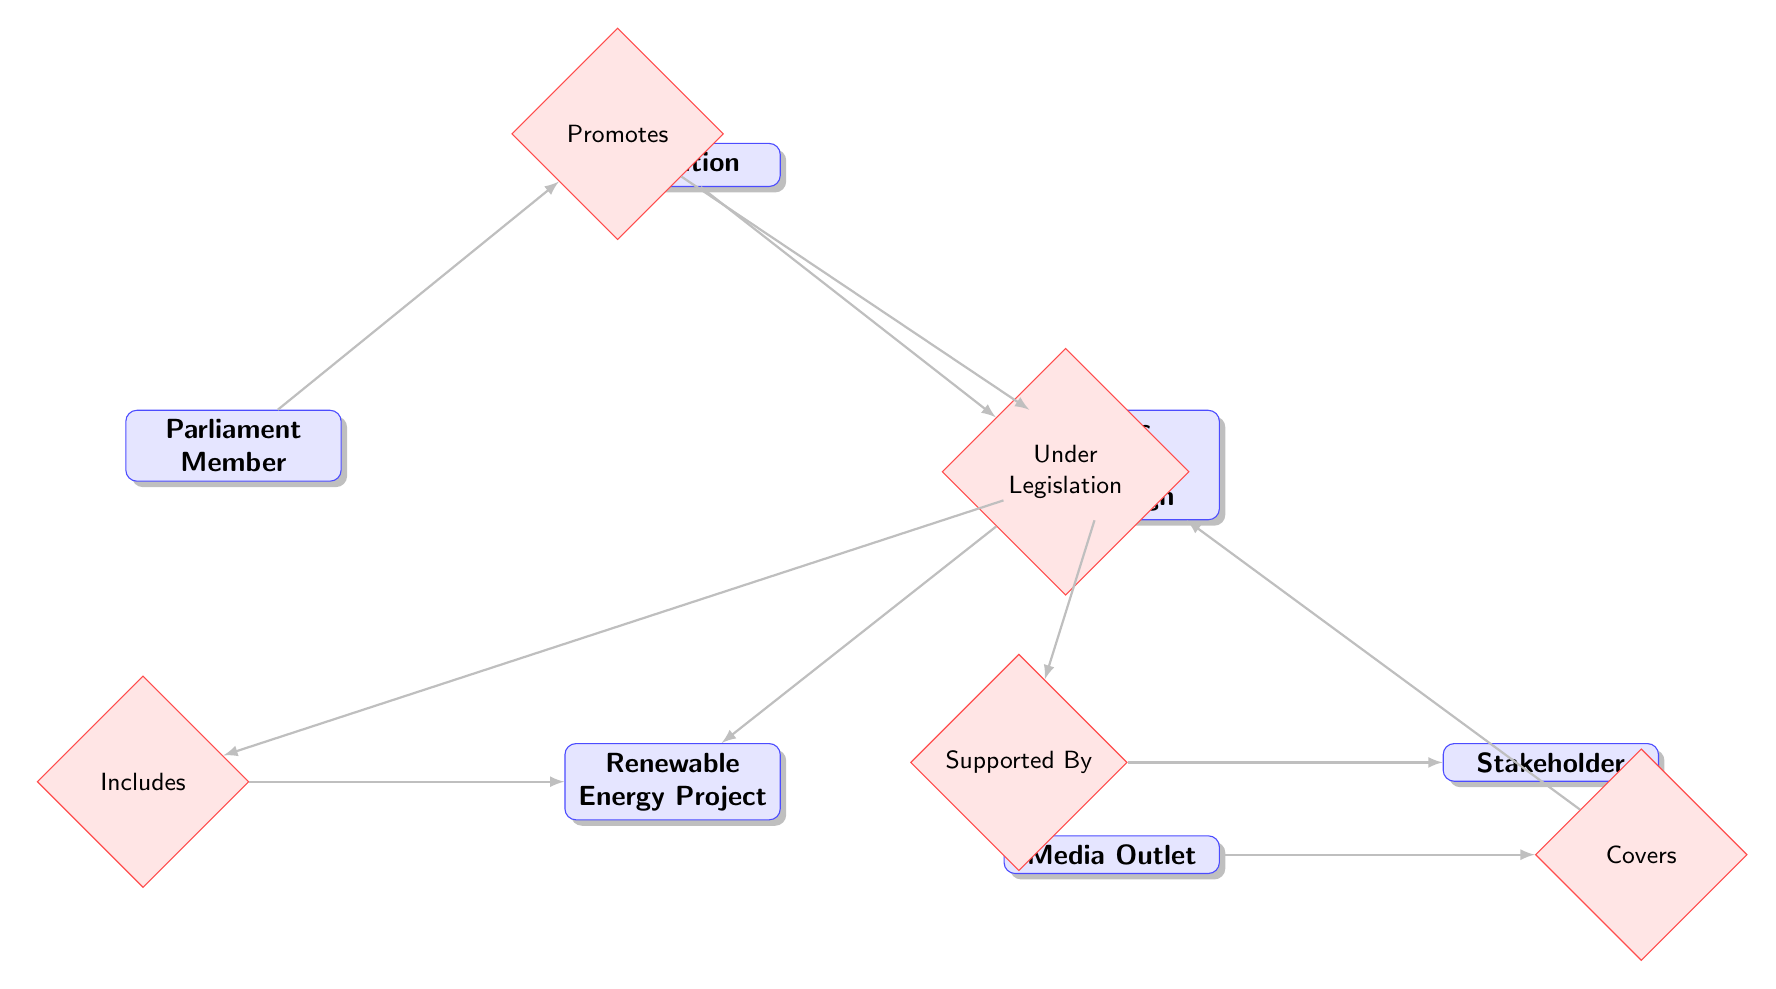What is the total number of entities in the diagram? The diagram lists six distinct entities: Legislation, Parliament Member, Public Awareness Campaign, Media Outlet, Renewable Energy Project, and Stakeholder. Counting these gives a total of 6 entities.
Answer: 6 Which entity is promoted by the Parliament Member? The relationship "Promotes" connects the Parliament Member to the Public Awareness Campaign, indicating that the Parliament Member is involved in promoting this campaign.
Answer: Public Awareness Campaign How many relationships are depicted in the diagram? The diagram features five relationships: Promotes, Covers, Includes, Supported By, and Under Legislation. Thus, the total number of relationships is 5.
Answer: 5 What is the target of the "Includes" relationship? The "Includes" relationship connects the Public Awareness Campaign to the Renewable Energy Project, signifying that the campaign includes this particular project.
Answer: Renewable Energy Project Which entity is covered by the Media Outlet? The relationship "Covers" indicates that the Media Outlet provides coverage for the Public Awareness Campaign, showing a direct connection in the diagram.
Answer: Public Awareness Campaign What type of relationship exists between the Public Awareness Campaign and Stakeholder? The relationship "Supported By" reflects the interaction between the Public Awareness Campaign and Stakeholder, indicating the campaign receives support from stakeholders.
Answer: Supported By Which entity is directly linked to Legislation through the relationship "Under"? The relationship "Under Legislation" connects Legislation to the Renewable Energy Project, indicating that this project operates under the specified legislation.
Answer: Renewable Energy Project Who promotes the Public Awareness Campaign? The diagram explicitly shows that a Parliament Member is involved in promoting the Public Awareness Campaign, indicating their active role in advocacy for renewable energy.
Answer: Parliament Member 